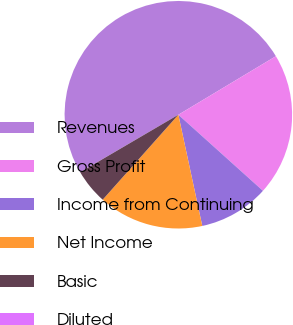<chart> <loc_0><loc_0><loc_500><loc_500><pie_chart><fcel>Revenues<fcel>Gross Profit<fcel>Income from Continuing<fcel>Net Income<fcel>Basic<fcel>Diluted<nl><fcel>49.81%<fcel>20.26%<fcel>9.97%<fcel>14.95%<fcel>4.99%<fcel>0.01%<nl></chart> 